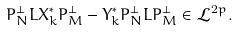Convert formula to latex. <formula><loc_0><loc_0><loc_500><loc_500>P _ { N } ^ { \perp } L X _ { k } ^ { * } P _ { M } ^ { \perp } - Y _ { k } ^ { * } P _ { N } ^ { \perp } L P _ { M } ^ { \perp } \in \mathcal { L } ^ { 2 p } .</formula> 